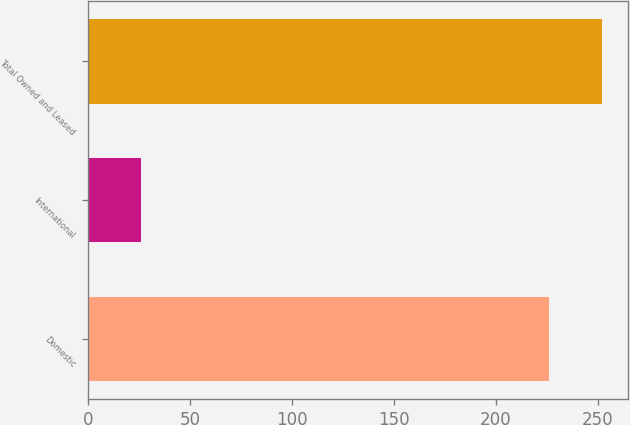Convert chart to OTSL. <chart><loc_0><loc_0><loc_500><loc_500><bar_chart><fcel>Domestic<fcel>International<fcel>Total Owned and Leased<nl><fcel>226<fcel>26<fcel>252<nl></chart> 